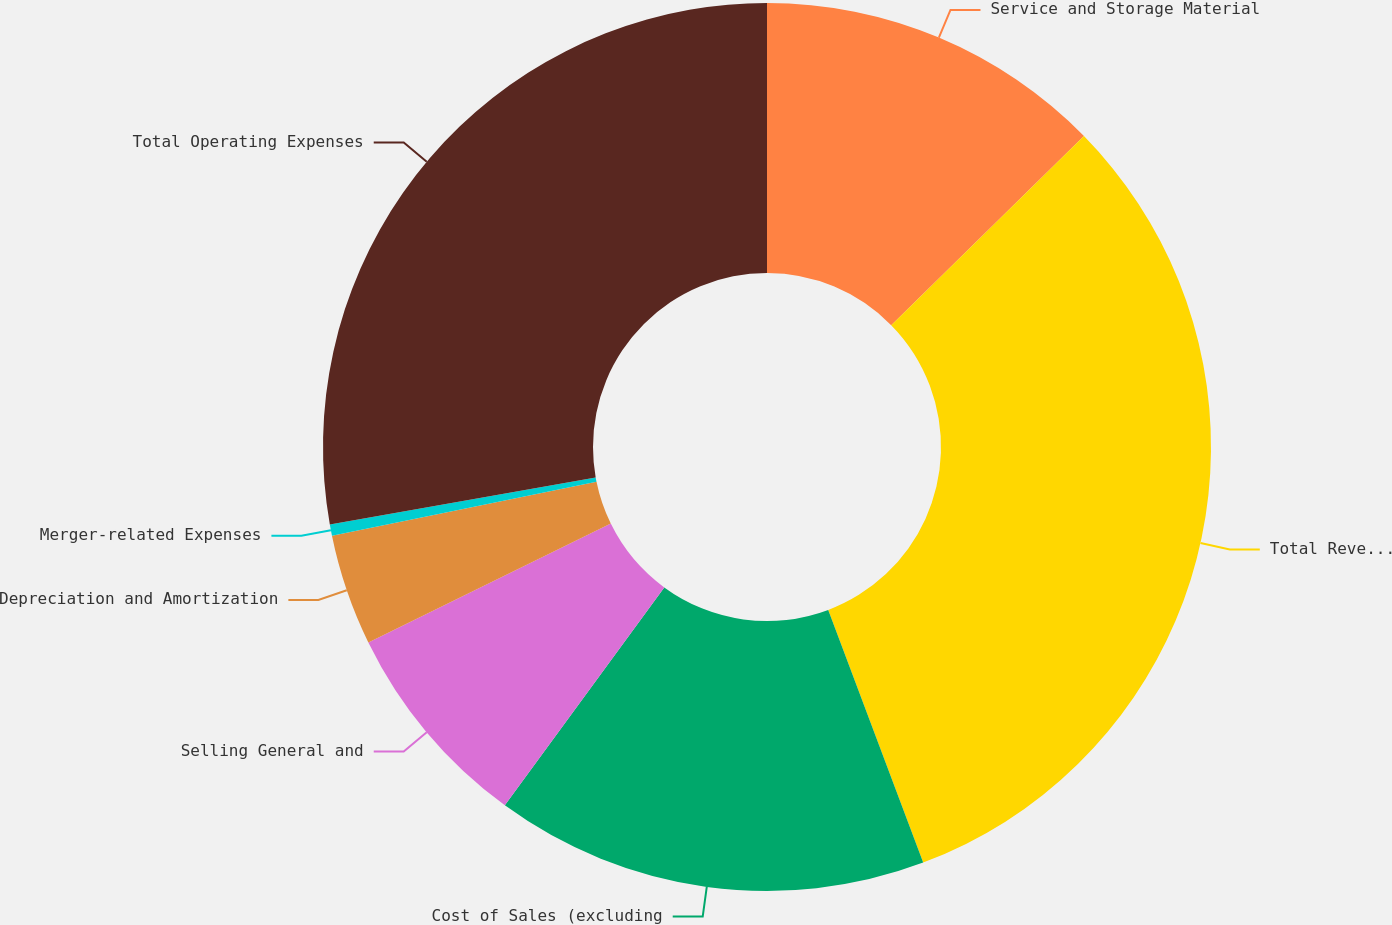Convert chart to OTSL. <chart><loc_0><loc_0><loc_500><loc_500><pie_chart><fcel>Service and Storage Material<fcel>Total Revenues<fcel>Cost of Sales (excluding<fcel>Selling General and<fcel>Depreciation and Amortization<fcel>Merger-related Expenses<fcel>Total Operating Expenses<nl><fcel>12.65%<fcel>31.62%<fcel>15.77%<fcel>7.69%<fcel>4.05%<fcel>0.41%<fcel>27.79%<nl></chart> 